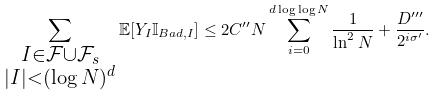<formula> <loc_0><loc_0><loc_500><loc_500>\sum _ { \substack { I \in \mathcal { F } \cup \mathcal { F } _ { s } \\ | I | < ( \log N ) ^ { d } } } \mathbb { E } [ Y _ { I } \mathbb { I } _ { B a d , I } ] \leq 2 C ^ { \prime \prime } N \sum _ { i = 0 } ^ { d \log \log N } \frac { 1 } { \ln ^ { 2 } N } + \frac { D ^ { \prime \prime \prime } } { 2 ^ { i \sigma ^ { \prime } } } .</formula> 